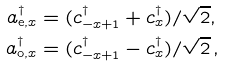Convert formula to latex. <formula><loc_0><loc_0><loc_500><loc_500>a _ { \mathrm e , x } ^ { \dagger } & = ( c _ { - x + 1 } ^ { \dagger } + c _ { x } ^ { \dagger } ) / { \sqrt { 2 } } , \\ a _ { \mathrm o , x } ^ { \dagger } & = ( c _ { - x + 1 } ^ { \dagger } - c _ { x } ^ { \dagger } ) / { \sqrt { 2 } } \, ,</formula> 